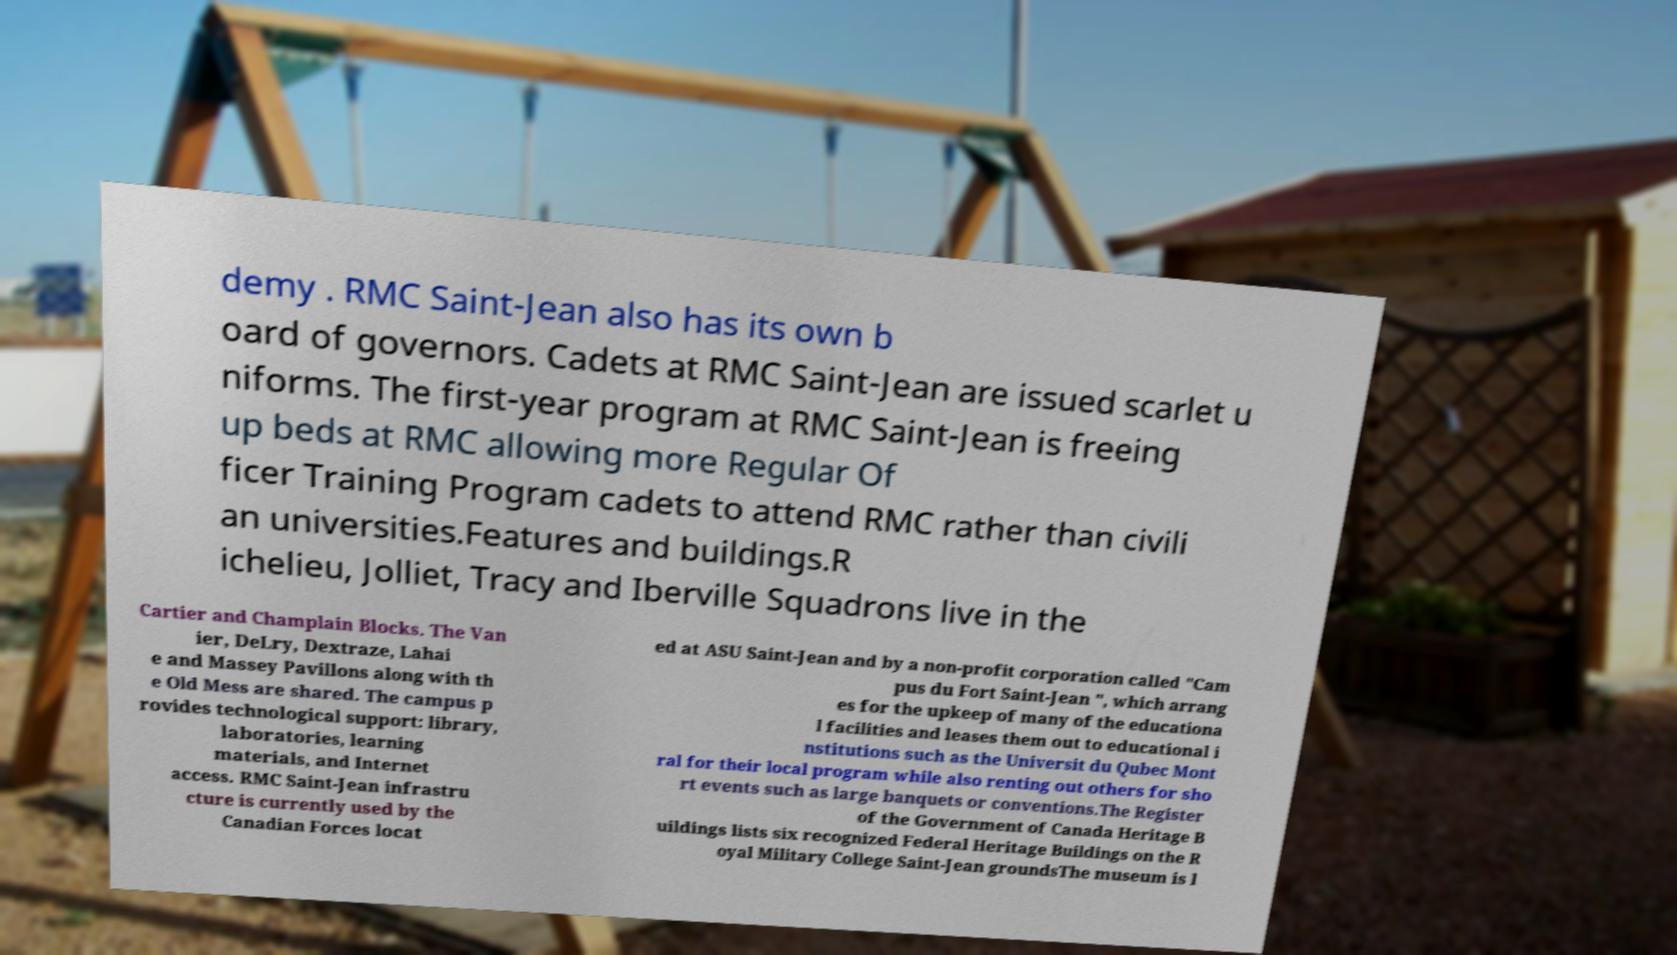Could you assist in decoding the text presented in this image and type it out clearly? demy . RMC Saint-Jean also has its own b oard of governors. Cadets at RMC Saint-Jean are issued scarlet u niforms. The first-year program at RMC Saint-Jean is freeing up beds at RMC allowing more Regular Of ficer Training Program cadets to attend RMC rather than civili an universities.Features and buildings.R ichelieu, Jolliet, Tracy and Iberville Squadrons live in the Cartier and Champlain Blocks. The Van ier, DeLry, Dextraze, Lahai e and Massey Pavillons along with th e Old Mess are shared. The campus p rovides technological support: library, laboratories, learning materials, and Internet access. RMC Saint-Jean infrastru cture is currently used by the Canadian Forces locat ed at ASU Saint-Jean and by a non-profit corporation called "Cam pus du Fort Saint-Jean ", which arrang es for the upkeep of many of the educationa l facilities and leases them out to educational i nstitutions such as the Universit du Qubec Mont ral for their local program while also renting out others for sho rt events such as large banquets or conventions.The Register of the Government of Canada Heritage B uildings lists six recognized Federal Heritage Buildings on the R oyal Military College Saint-Jean groundsThe museum is l 